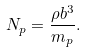<formula> <loc_0><loc_0><loc_500><loc_500>N _ { p } = \frac { \rho b ^ { 3 } } { m _ { p } } .</formula> 